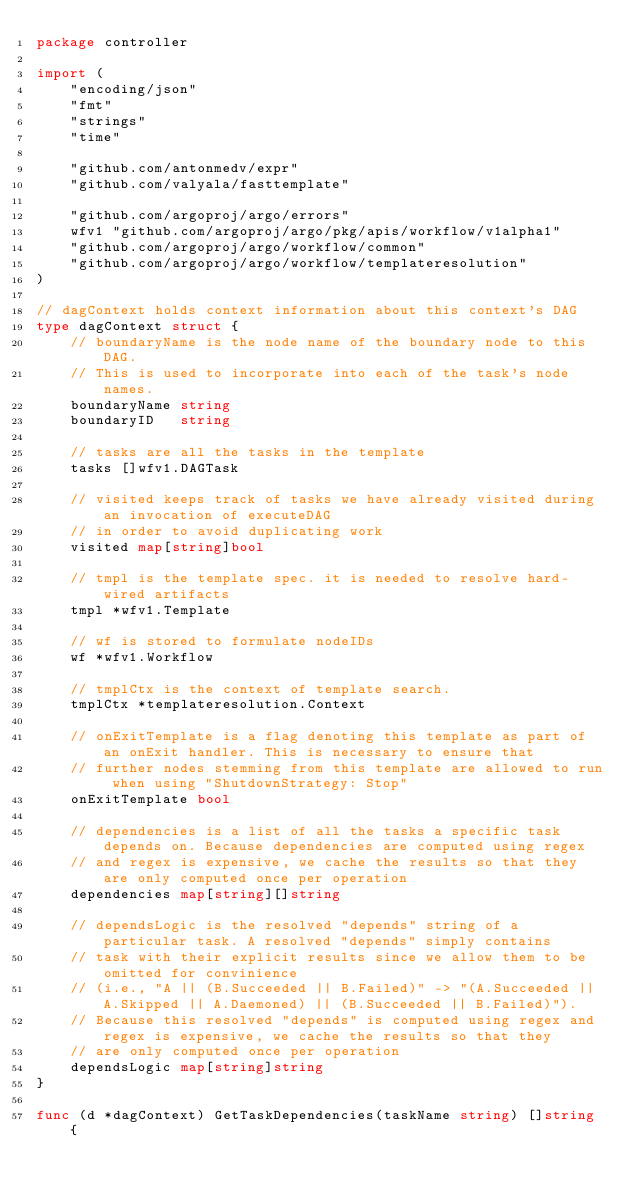Convert code to text. <code><loc_0><loc_0><loc_500><loc_500><_Go_>package controller

import (
	"encoding/json"
	"fmt"
	"strings"
	"time"

	"github.com/antonmedv/expr"
	"github.com/valyala/fasttemplate"

	"github.com/argoproj/argo/errors"
	wfv1 "github.com/argoproj/argo/pkg/apis/workflow/v1alpha1"
	"github.com/argoproj/argo/workflow/common"
	"github.com/argoproj/argo/workflow/templateresolution"
)

// dagContext holds context information about this context's DAG
type dagContext struct {
	// boundaryName is the node name of the boundary node to this DAG.
	// This is used to incorporate into each of the task's node names.
	boundaryName string
	boundaryID   string

	// tasks are all the tasks in the template
	tasks []wfv1.DAGTask

	// visited keeps track of tasks we have already visited during an invocation of executeDAG
	// in order to avoid duplicating work
	visited map[string]bool

	// tmpl is the template spec. it is needed to resolve hard-wired artifacts
	tmpl *wfv1.Template

	// wf is stored to formulate nodeIDs
	wf *wfv1.Workflow

	// tmplCtx is the context of template search.
	tmplCtx *templateresolution.Context

	// onExitTemplate is a flag denoting this template as part of an onExit handler. This is necessary to ensure that
	// further nodes stemming from this template are allowed to run when using "ShutdownStrategy: Stop"
	onExitTemplate bool

	// dependencies is a list of all the tasks a specific task depends on. Because dependencies are computed using regex
	// and regex is expensive, we cache the results so that they are only computed once per operation
	dependencies map[string][]string

	// dependsLogic is the resolved "depends" string of a particular task. A resolved "depends" simply contains
	// task with their explicit results since we allow them to be omitted for convinience
	// (i.e., "A || (B.Succeeded || B.Failed)" -> "(A.Succeeded || A.Skipped || A.Daemoned) || (B.Succeeded || B.Failed)").
	// Because this resolved "depends" is computed using regex and regex is expensive, we cache the results so that they
	// are only computed once per operation
	dependsLogic map[string]string
}

func (d *dagContext) GetTaskDependencies(taskName string) []string {</code> 